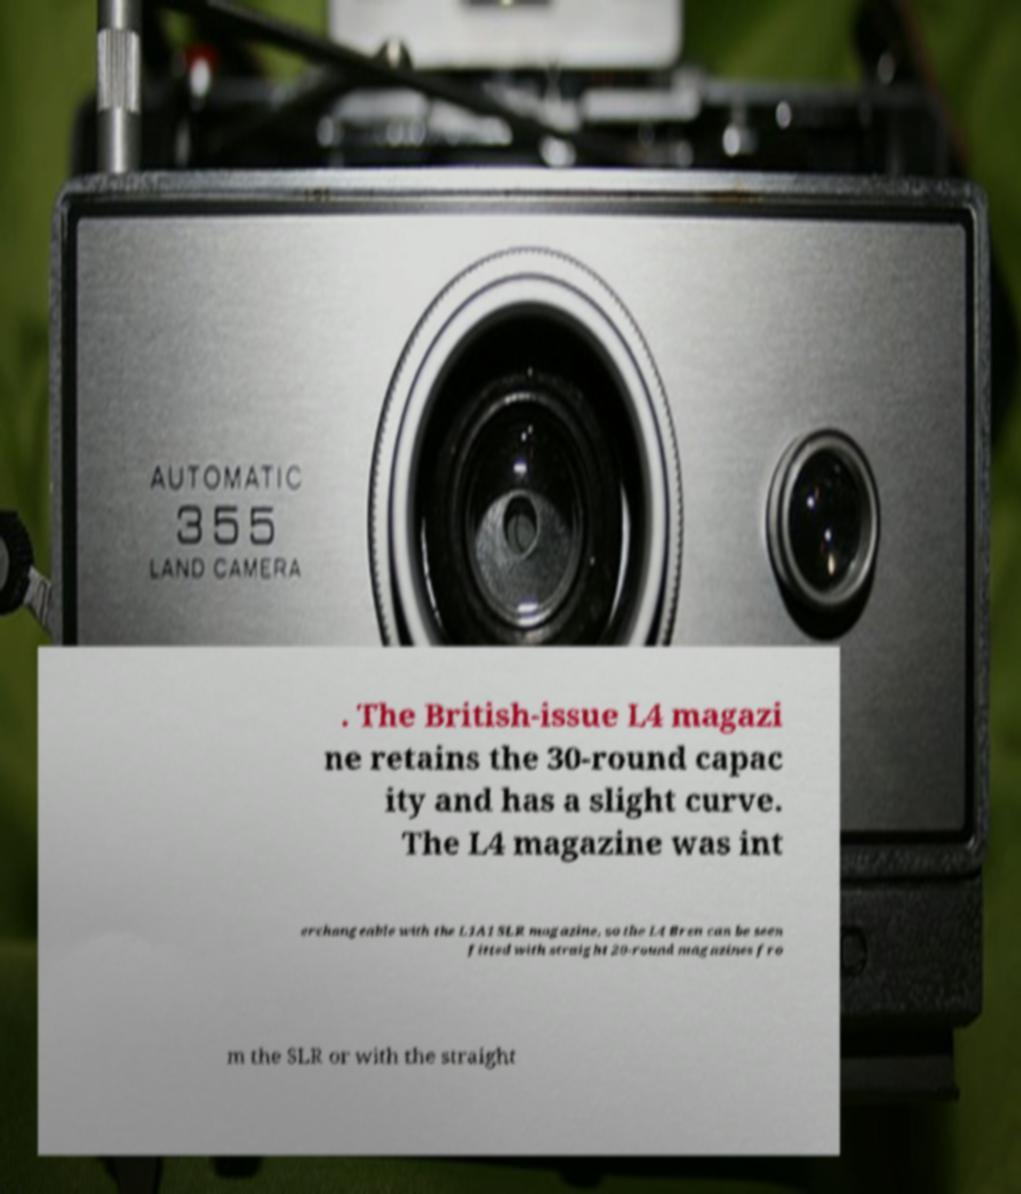Please identify and transcribe the text found in this image. . The British-issue L4 magazi ne retains the 30-round capac ity and has a slight curve. The L4 magazine was int erchangeable with the L1A1 SLR magazine, so the L4 Bren can be seen fitted with straight 20-round magazines fro m the SLR or with the straight 